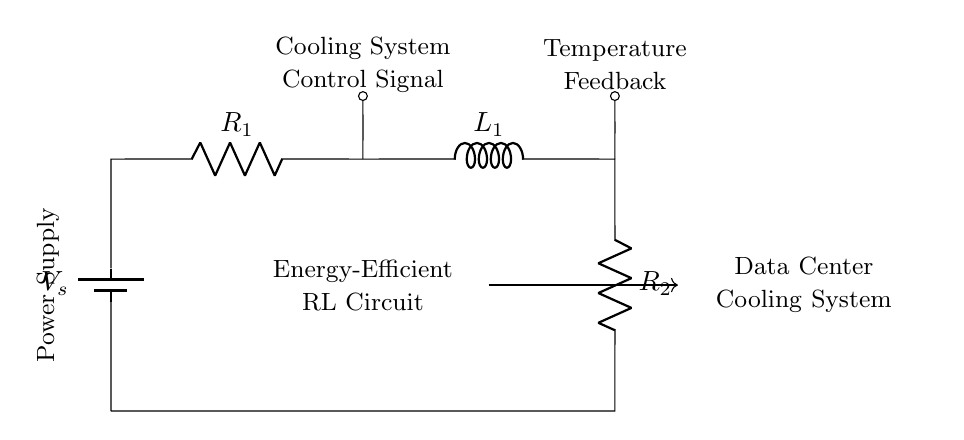What is the total resistance in the circuit? The total resistance is the sum of both resistors, R1 and R2. The circuit indicates that these resistors are in series, so the equation is R_total = R1 + R2.
Answer: R1 + R2 What type of circuit is represented here? The circuit comprises resistive and inductive components arranged in a manner that suggests it is an RL circuit, specifically for energy efficiency in cooling systems.
Answer: RL circuit What is the purpose of the control signal in the circuit? The control signal is used to regulate the cooling system by adjusting the energy input or flow based on temperature feedback. This dynamic control is crucial for maintaining optimal cooling conditions.
Answer: Regulation Which components are responsible for energy storage in this circuit? The inductor (L1) is the component responsible for energy storage in this circuit. Inductors store energy in a magnetic field when electric current flows through them.
Answer: L1 How does the temperature feedback affect the circuit operation? The temperature feedback provides a mechanism to adjust the cooling system's performance based on the current temperature, facilitating a responsive operation that maintains energy efficiency. By modifying current or voltage based on this feedback, the system can optimize cooling output.
Answer: Optimization 